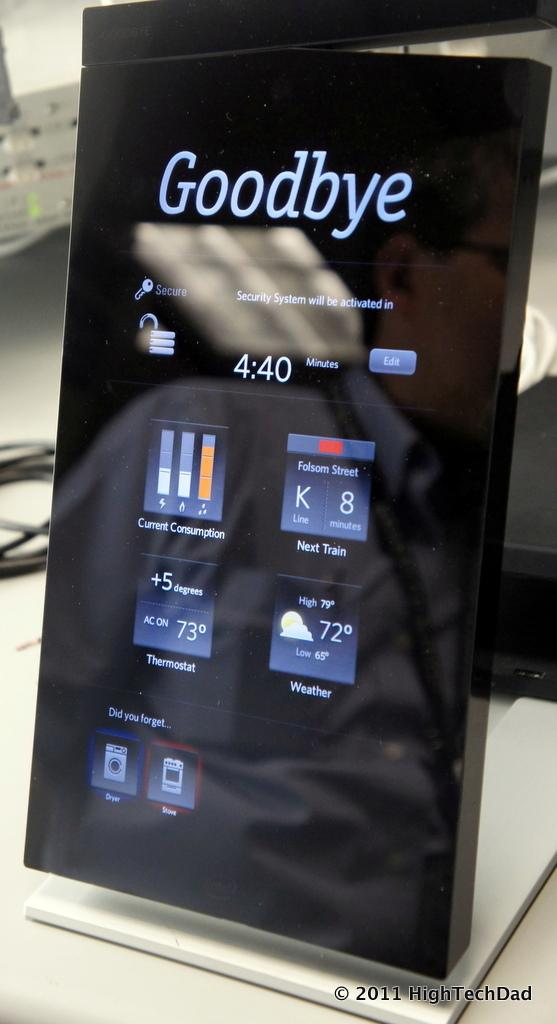<image>
Relay a brief, clear account of the picture shown. A black box displays the text Goodbye at the top above a couple of icons. 